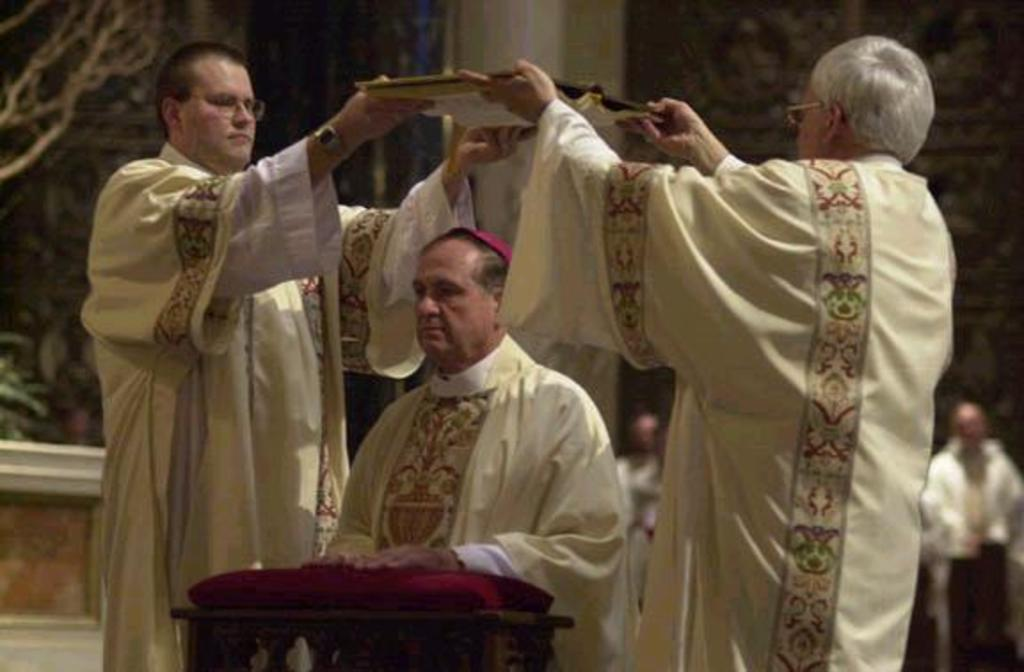What event is taking place in the image? An ordination of a bishop is being performed in the image. Can you describe the people in the background of the image? The people in the background are blurred, so it is difficult to provide specific details about them. What type of camp can be seen in the image? There is no camp present in the image; it features an ordination of a bishop. What error is being corrected during the ordination in the image? The image does not depict any errors being corrected; it simply shows the ordination of a bishop. 